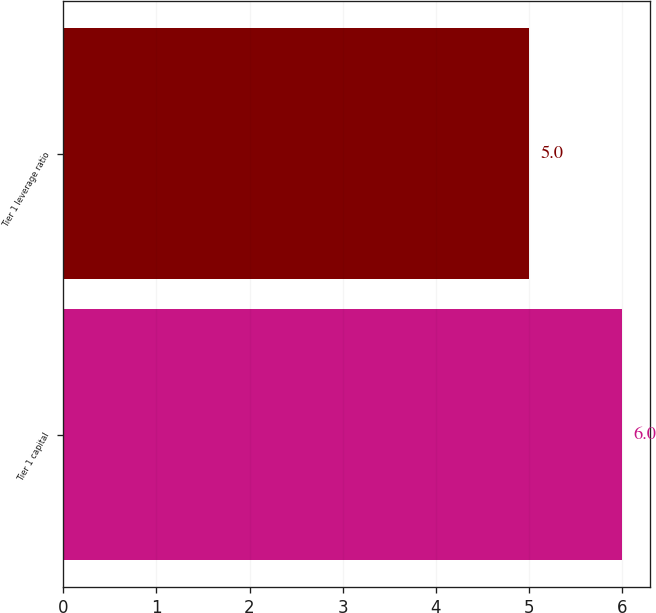<chart> <loc_0><loc_0><loc_500><loc_500><bar_chart><fcel>Tier 1 capital<fcel>Tier 1 leverage ratio<nl><fcel>6<fcel>5<nl></chart> 